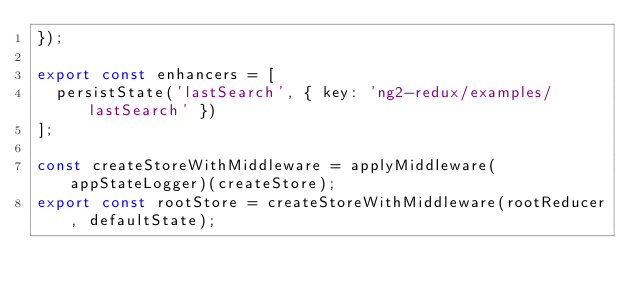Convert code to text. <code><loc_0><loc_0><loc_500><loc_500><_TypeScript_>});

export const enhancers = [
  persistState('lastSearch', { key: 'ng2-redux/examples/lastSearch' })
];

const createStoreWithMiddleware = applyMiddleware(appStateLogger)(createStore);
export const rootStore = createStoreWithMiddleware(rootReducer, defaultState);
</code> 